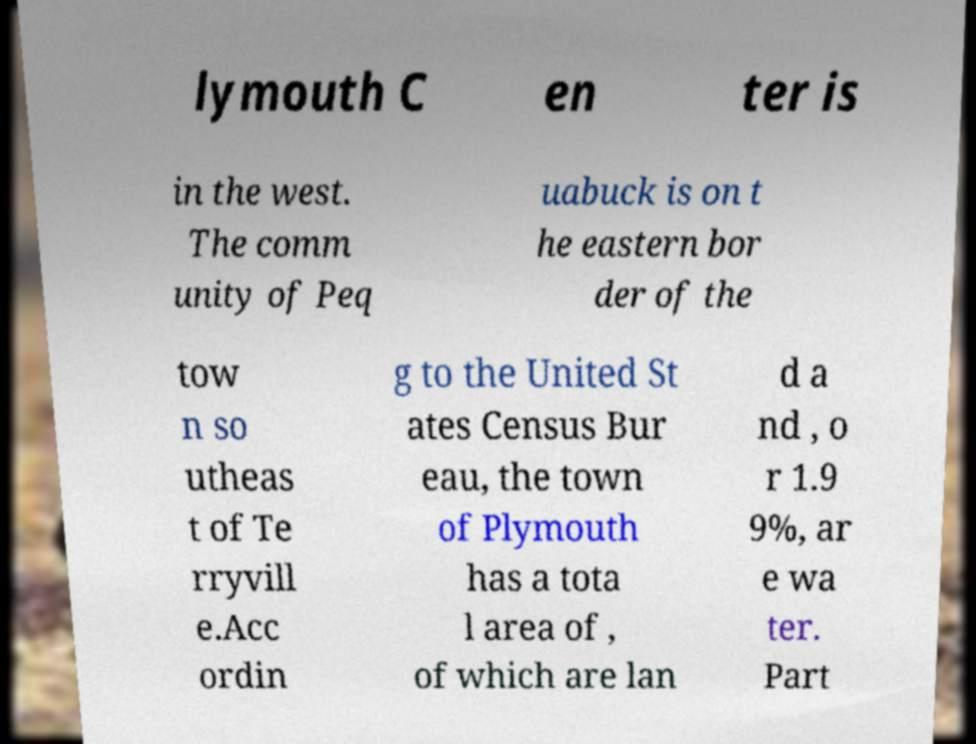What messages or text are displayed in this image? I need them in a readable, typed format. lymouth C en ter is in the west. The comm unity of Peq uabuck is on t he eastern bor der of the tow n so utheas t of Te rryvill e.Acc ordin g to the United St ates Census Bur eau, the town of Plymouth has a tota l area of , of which are lan d a nd , o r 1.9 9%, ar e wa ter. Part 